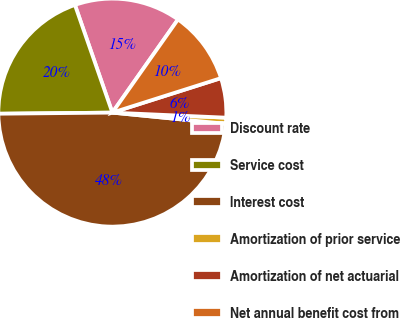Convert chart to OTSL. <chart><loc_0><loc_0><loc_500><loc_500><pie_chart><fcel>Discount rate<fcel>Service cost<fcel>Interest cost<fcel>Amortization of prior service<fcel>Amortization of net actuarial<fcel>Net annual benefit cost from<nl><fcel>15.09%<fcel>19.83%<fcel>48.28%<fcel>0.86%<fcel>5.6%<fcel>10.34%<nl></chart> 